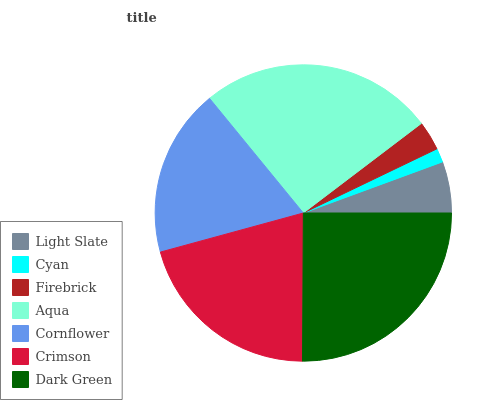Is Cyan the minimum?
Answer yes or no. Yes. Is Aqua the maximum?
Answer yes or no. Yes. Is Firebrick the minimum?
Answer yes or no. No. Is Firebrick the maximum?
Answer yes or no. No. Is Firebrick greater than Cyan?
Answer yes or no. Yes. Is Cyan less than Firebrick?
Answer yes or no. Yes. Is Cyan greater than Firebrick?
Answer yes or no. No. Is Firebrick less than Cyan?
Answer yes or no. No. Is Cornflower the high median?
Answer yes or no. Yes. Is Cornflower the low median?
Answer yes or no. Yes. Is Crimson the high median?
Answer yes or no. No. Is Firebrick the low median?
Answer yes or no. No. 